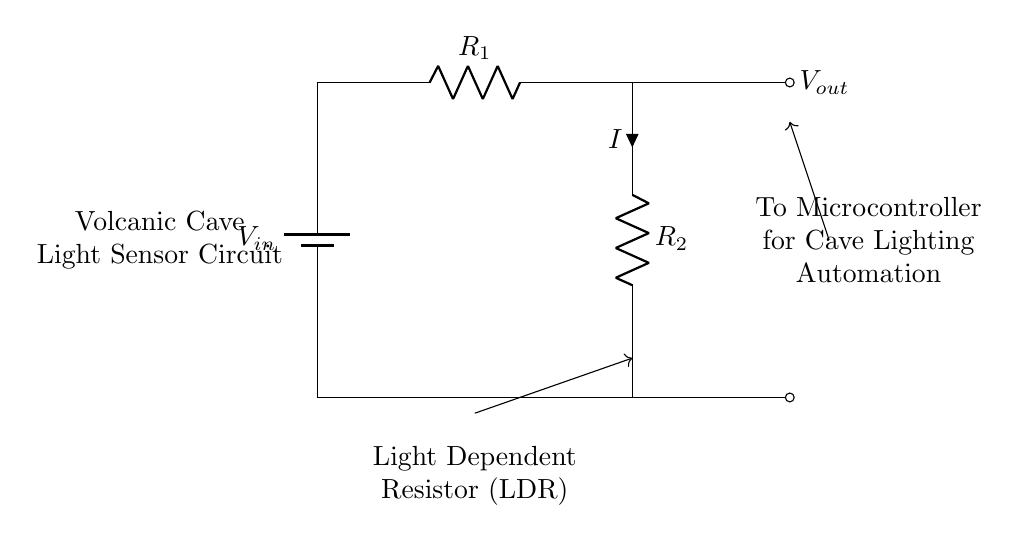What is the input voltage? The input voltage is denoted as \(V_{in}\) in the circuit diagram, which represents the voltage supplied to the circuit.
Answer: \(V_{in}\) What type of resistor is used in the circuit? The circuit includes a Light Dependent Resistor (LDR) which is utilized for detecting light levels. The label specifically identifies it as an LDR.
Answer: Light Dependent Resistor What is the function of \(V_{out}\) in this circuit? \(V_{out}\) represents the output voltage from the voltage divider formed by the resistors. This voltage is then used to inform the microcontroller about the light levels.
Answer: Output voltage Which components are in series in this voltage divider? The two resistors, \(R_1\) and \(R_2\), are in series because they are connected end-to-end, allowing the same current to flow through both.
Answer: \(R_1\) and \(R_2\) How does the light sensor affect the output voltage? The output voltage changes based on the resistance of the LDR, which varies with light intensity. A higher light intensity results in lower resistance and a higher output voltage.
Answer: Changes output voltage What is the connection between \(V_{out}\) and the microcontroller? \(V_{out}\) is connected to the microcontroller, which uses this voltage level for making decisions about cave lighting automation based on the light sensed.
Answer: To the microcontroller How many resistors are present in the circuit? There are two resistors present in this voltage divider circuit, identified as \(R_1\) and \(R_2\).
Answer: Two resistors 